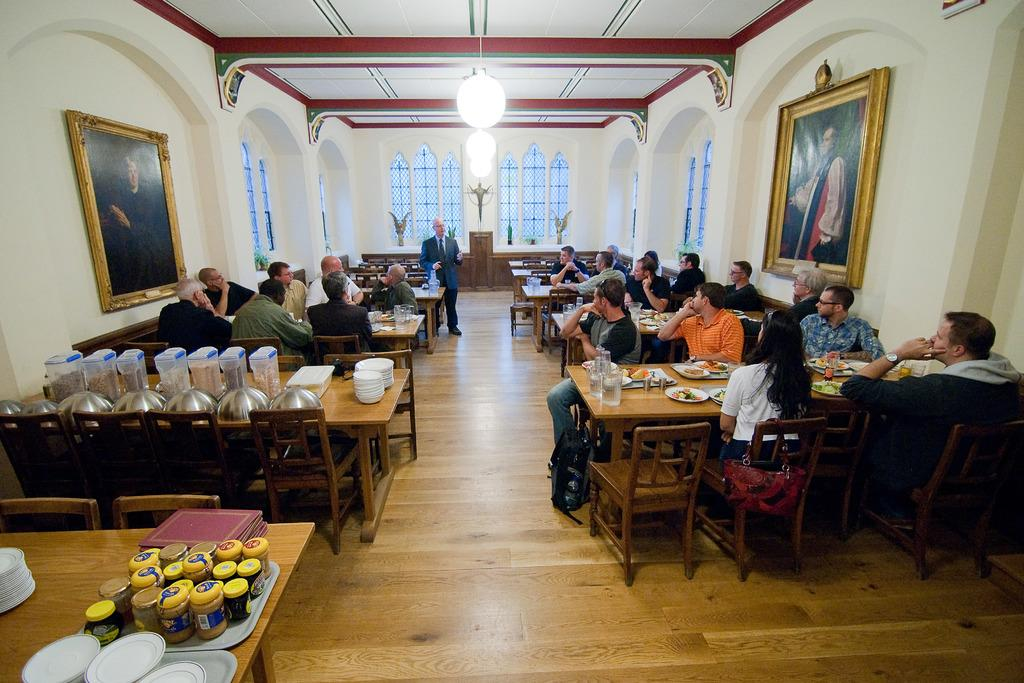What is the main activity of the people in the image? The people in the image are sitting at tables. What is the man in the image doing? The man is standing and speaking. How are the people interacting with the man? The people are listening to the man. What type of eggs are being used in the game on the field in the image? There is no game or field present in the image, and therefore no eggs are involved. How many balls are visible in the image? There are no balls visible in the image. 